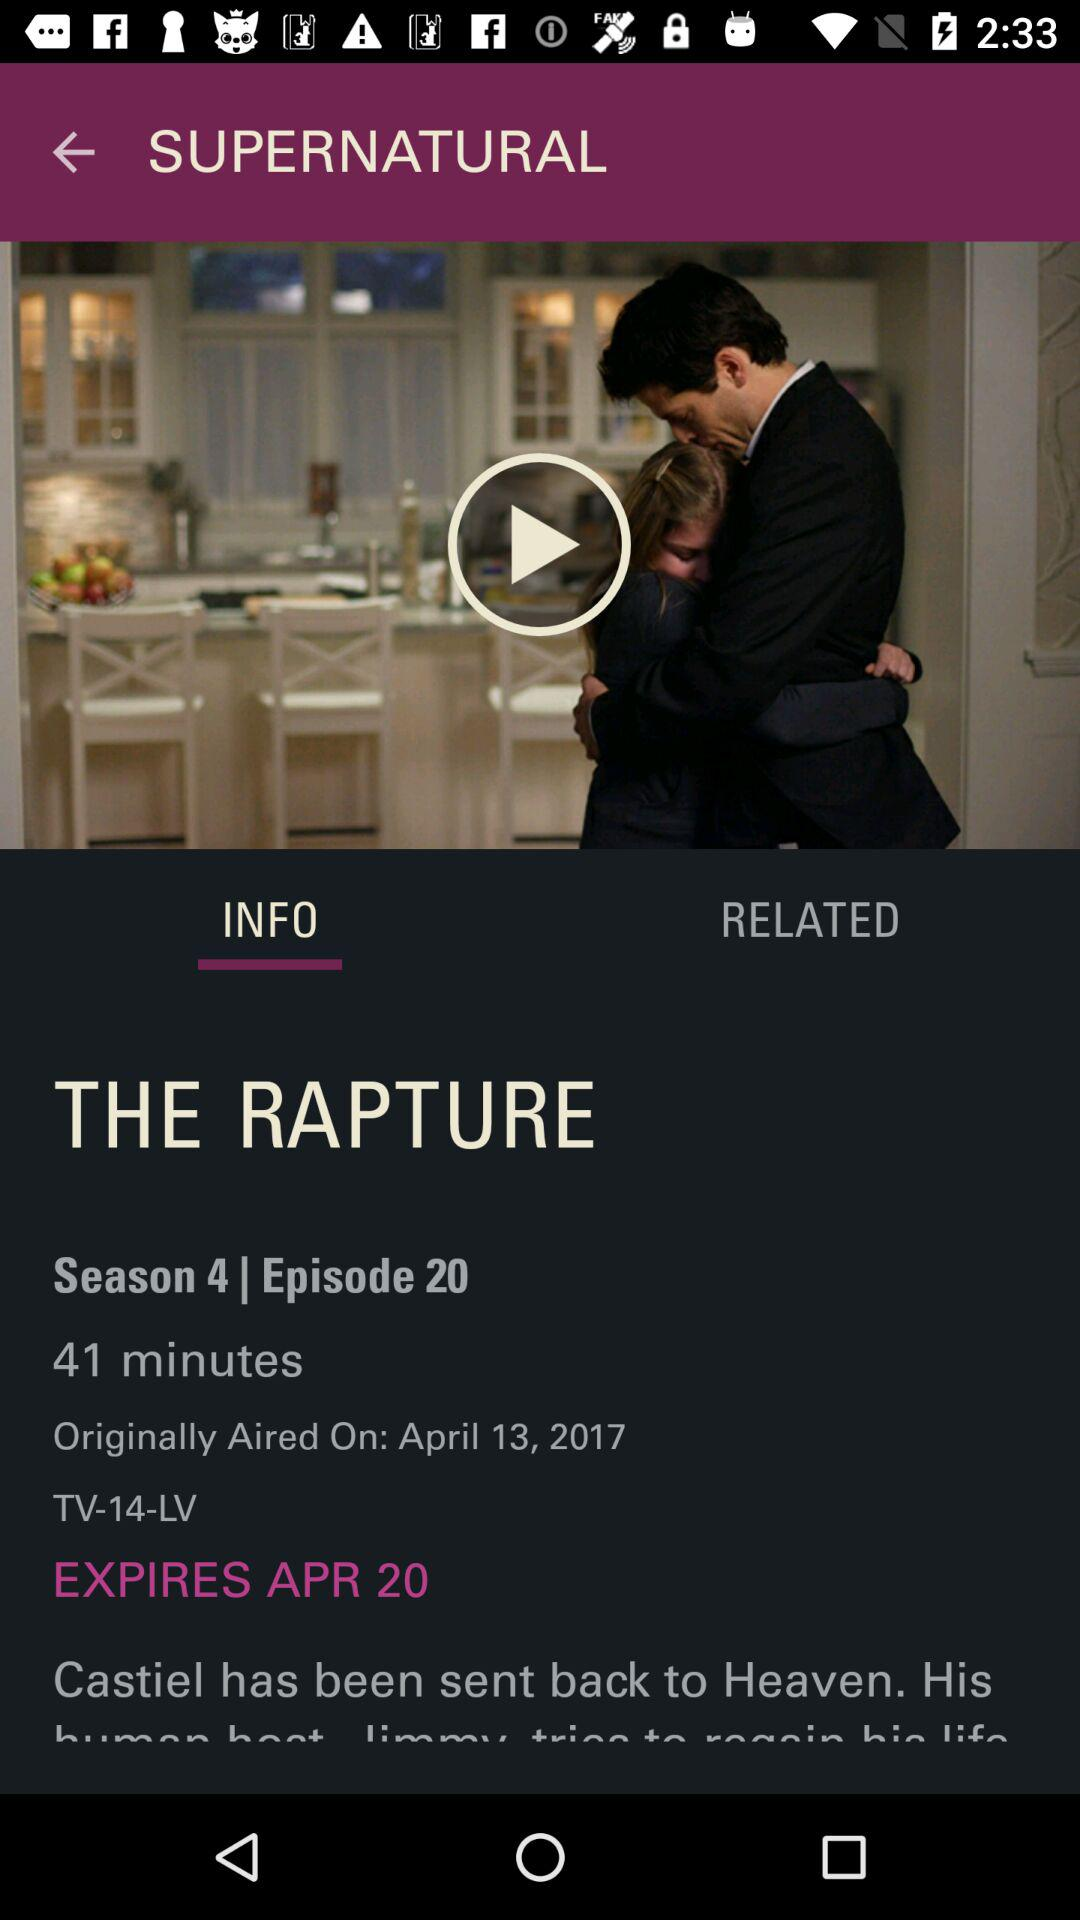How long is the episode? The episode is 41 minutes long. 